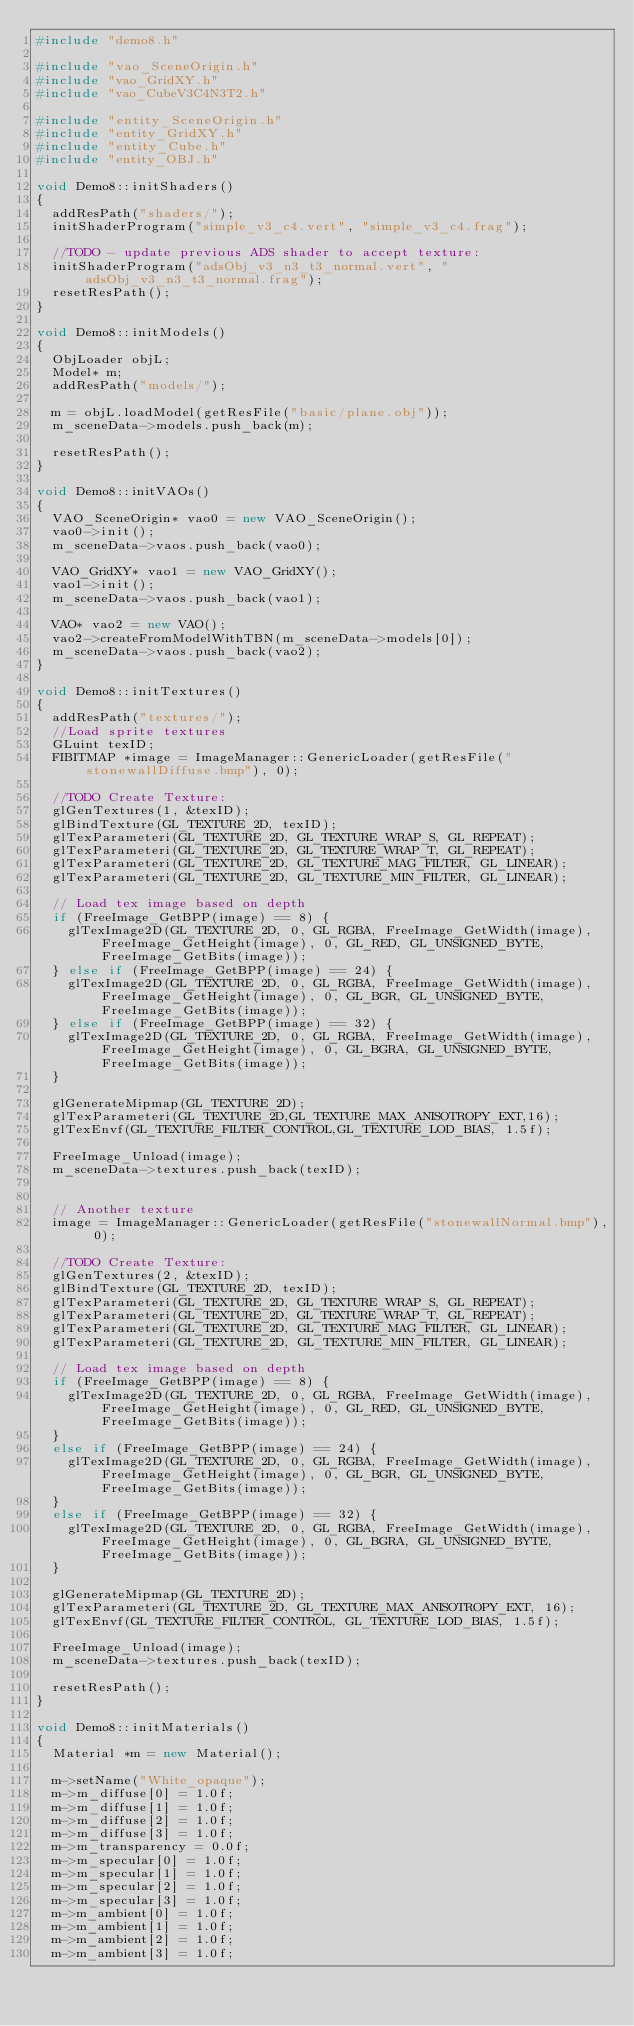Convert code to text. <code><loc_0><loc_0><loc_500><loc_500><_C++_>#include "demo8.h"

#include "vao_SceneOrigin.h"
#include "vao_GridXY.h"
#include "vao_CubeV3C4N3T2.h"

#include "entity_SceneOrigin.h"
#include "entity_GridXY.h"
#include "entity_Cube.h"
#include "entity_OBJ.h"

void Demo8::initShaders()
{
	addResPath("shaders/");
	initShaderProgram("simple_v3_c4.vert", "simple_v3_c4.frag");
	
	//TODO - update previous ADS shader to accept texture:
	initShaderProgram("adsObj_v3_n3_t3_normal.vert", "adsObj_v3_n3_t3_normal.frag");
	resetResPath();
}

void Demo8::initModels()
{
	ObjLoader objL;
	Model* m;
	addResPath("models/");

	m = objL.loadModel(getResFile("basic/plane.obj"));
	m_sceneData->models.push_back(m);

	resetResPath();
}

void Demo8::initVAOs()
{
	VAO_SceneOrigin* vao0 = new VAO_SceneOrigin();
	vao0->init();
	m_sceneData->vaos.push_back(vao0);

	VAO_GridXY* vao1 = new VAO_GridXY();
	vao1->init();
	m_sceneData->vaos.push_back(vao1);

	VAO* vao2 = new VAO();
	vao2->createFromModelWithTBN(m_sceneData->models[0]);
	m_sceneData->vaos.push_back(vao2);
}

void Demo8::initTextures()
{
	addResPath("textures/");
	//Load sprite textures
	GLuint texID;
	FIBITMAP *image = ImageManager::GenericLoader(getResFile("stonewallDiffuse.bmp"), 0);

	//TODO Create Texture:
	glGenTextures(1, &texID);
	glBindTexture(GL_TEXTURE_2D, texID);
	glTexParameteri(GL_TEXTURE_2D, GL_TEXTURE_WRAP_S, GL_REPEAT);
	glTexParameteri(GL_TEXTURE_2D, GL_TEXTURE_WRAP_T, GL_REPEAT);
	glTexParameteri(GL_TEXTURE_2D, GL_TEXTURE_MAG_FILTER, GL_LINEAR);
	glTexParameteri(GL_TEXTURE_2D, GL_TEXTURE_MIN_FILTER, GL_LINEAR);

	// Load tex image based on depth
	if (FreeImage_GetBPP(image) == 8) {
		glTexImage2D(GL_TEXTURE_2D, 0, GL_RGBA, FreeImage_GetWidth(image), FreeImage_GetHeight(image), 0, GL_RED, GL_UNSIGNED_BYTE, FreeImage_GetBits(image));
	} else if (FreeImage_GetBPP(image) == 24) {
		glTexImage2D(GL_TEXTURE_2D, 0, GL_RGBA, FreeImage_GetWidth(image), FreeImage_GetHeight(image), 0, GL_BGR, GL_UNSIGNED_BYTE, FreeImage_GetBits(image));
	} else if (FreeImage_GetBPP(image) == 32) {
		glTexImage2D(GL_TEXTURE_2D, 0, GL_RGBA, FreeImage_GetWidth(image), FreeImage_GetHeight(image), 0, GL_BGRA, GL_UNSIGNED_BYTE, FreeImage_GetBits(image));
	}

	glGenerateMipmap(GL_TEXTURE_2D);
	glTexParameteri(GL_TEXTURE_2D,GL_TEXTURE_MAX_ANISOTROPY_EXT,16);
	glTexEnvf(GL_TEXTURE_FILTER_CONTROL,GL_TEXTURE_LOD_BIAS, 1.5f);

	FreeImage_Unload(image);
	m_sceneData->textures.push_back(texID);
	

	// Another texture
	image = ImageManager::GenericLoader(getResFile("stonewallNormal.bmp"), 0);

	//TODO Create Texture:
	glGenTextures(2, &texID);
	glBindTexture(GL_TEXTURE_2D, texID);
	glTexParameteri(GL_TEXTURE_2D, GL_TEXTURE_WRAP_S, GL_REPEAT);
	glTexParameteri(GL_TEXTURE_2D, GL_TEXTURE_WRAP_T, GL_REPEAT);
	glTexParameteri(GL_TEXTURE_2D, GL_TEXTURE_MAG_FILTER, GL_LINEAR);
	glTexParameteri(GL_TEXTURE_2D, GL_TEXTURE_MIN_FILTER, GL_LINEAR);

	// Load tex image based on depth
	if (FreeImage_GetBPP(image) == 8) {
		glTexImage2D(GL_TEXTURE_2D, 0, GL_RGBA, FreeImage_GetWidth(image), FreeImage_GetHeight(image), 0, GL_RED, GL_UNSIGNED_BYTE, FreeImage_GetBits(image));
	}
	else if (FreeImage_GetBPP(image) == 24) {
		glTexImage2D(GL_TEXTURE_2D, 0, GL_RGBA, FreeImage_GetWidth(image), FreeImage_GetHeight(image), 0, GL_BGR, GL_UNSIGNED_BYTE, FreeImage_GetBits(image));
	}
	else if (FreeImage_GetBPP(image) == 32) {
		glTexImage2D(GL_TEXTURE_2D, 0, GL_RGBA, FreeImage_GetWidth(image), FreeImage_GetHeight(image), 0, GL_BGRA, GL_UNSIGNED_BYTE, FreeImage_GetBits(image));
	}

	glGenerateMipmap(GL_TEXTURE_2D);
	glTexParameteri(GL_TEXTURE_2D, GL_TEXTURE_MAX_ANISOTROPY_EXT, 16);
	glTexEnvf(GL_TEXTURE_FILTER_CONTROL, GL_TEXTURE_LOD_BIAS, 1.5f);

	FreeImage_Unload(image);
	m_sceneData->textures.push_back(texID);

	resetResPath();
}

void Demo8::initMaterials()
{
	Material *m = new Material();

	m->setName("White_opaque");
	m->m_diffuse[0] = 1.0f;
	m->m_diffuse[1] = 1.0f;
	m->m_diffuse[2] = 1.0f;
	m->m_diffuse[3] = 1.0f;
	m->m_transparency = 0.0f;
	m->m_specular[0] = 1.0f;
	m->m_specular[1] = 1.0f;
	m->m_specular[2] = 1.0f;
	m->m_specular[3] = 1.0f;
	m->m_ambient[0] = 1.0f;
	m->m_ambient[1] = 1.0f;
	m->m_ambient[2] = 1.0f;
	m->m_ambient[3] = 1.0f;
</code> 